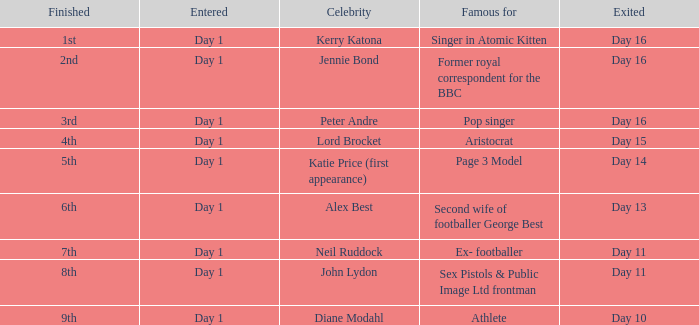Name who was famous for finished in 9th Athlete. 